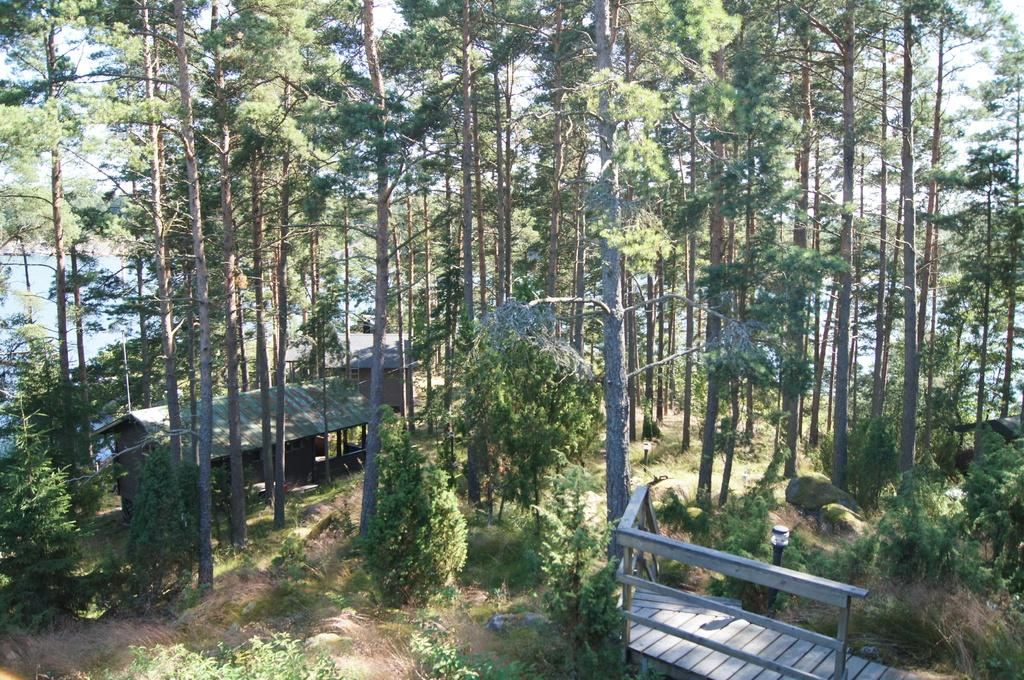What type of house is in the center of the image? There is a wooden house in the center of the image. What can be seen in the background of the image? There are trees in the background of the image. What type of vegetation is at the bottom of the image? There is grass at the bottom of the image. What type of ice can be seen melting on the chin of the person in the image? There is no person present in the image, and therefore no ice or chin can be observed. 